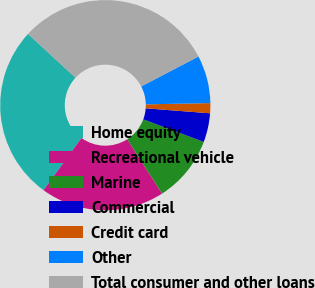Convert chart. <chart><loc_0><loc_0><loc_500><loc_500><pie_chart><fcel>Home equity<fcel>Recreational vehicle<fcel>Marine<fcel>Commercial<fcel>Credit card<fcel>Other<fcel>Total consumer and other loans<nl><fcel>26.86%<fcel>19.08%<fcel>10.23%<fcel>4.45%<fcel>1.55%<fcel>7.34%<fcel>30.48%<nl></chart> 